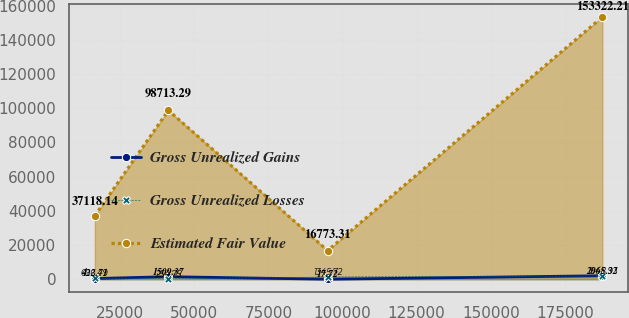Convert chart to OTSL. <chart><loc_0><loc_0><loc_500><loc_500><line_chart><ecel><fcel>Gross Unrealized Gains<fcel>Gross Unrealized Losses<fcel>Estimated Fair Value<nl><fcel>16479.9<fcel>422.71<fcel>696.49<fcel>37118.1<nl><fcel>41281.8<fcel>1509.37<fcel>254.75<fcel>98713.3<nl><fcel>94993.2<fcel>17.72<fcel>1345.72<fcel>16773.3<nl><fcel>187638<fcel>2065.32<fcel>1948.93<fcel>153322<nl></chart> 